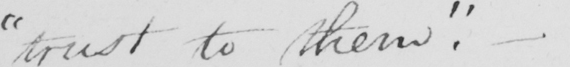Transcribe the text shown in this historical manuscript line. " trust to them . " 